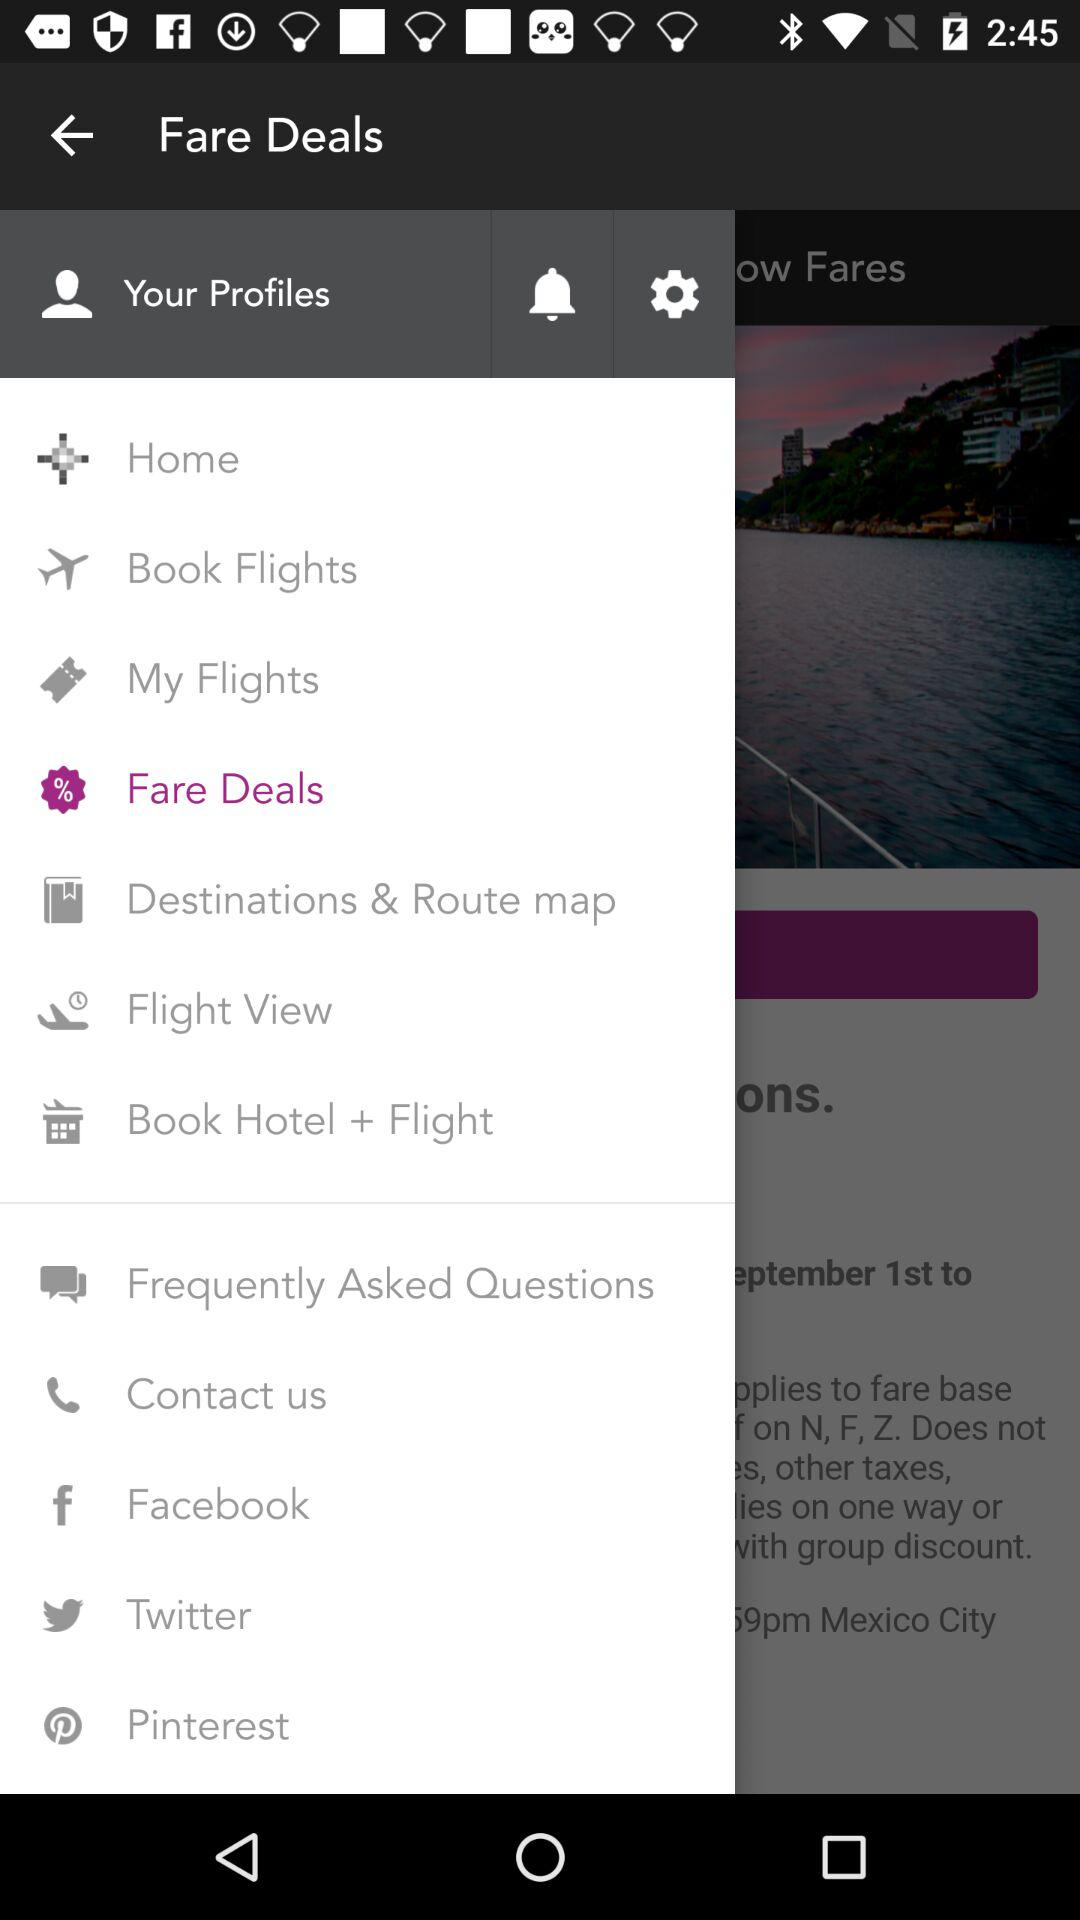Which option is selected? The selected option is "Fare Deals". 